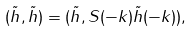Convert formula to latex. <formula><loc_0><loc_0><loc_500><loc_500>( \tilde { h } , \tilde { h } ) = ( \tilde { h } , S ( - k ) \tilde { h } ( - k ) ) ,</formula> 